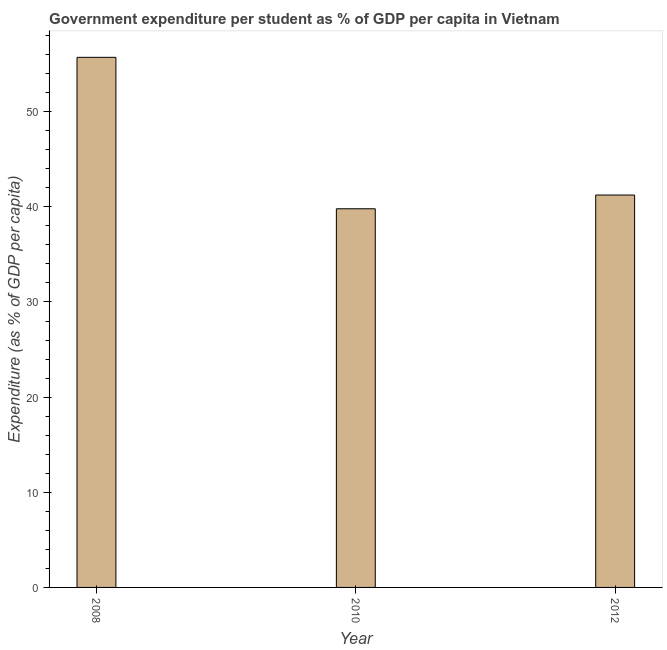What is the title of the graph?
Offer a very short reply. Government expenditure per student as % of GDP per capita in Vietnam. What is the label or title of the X-axis?
Ensure brevity in your answer.  Year. What is the label or title of the Y-axis?
Provide a succinct answer. Expenditure (as % of GDP per capita). What is the government expenditure per student in 2010?
Keep it short and to the point. 39.8. Across all years, what is the maximum government expenditure per student?
Offer a terse response. 55.71. Across all years, what is the minimum government expenditure per student?
Provide a succinct answer. 39.8. In which year was the government expenditure per student maximum?
Keep it short and to the point. 2008. What is the sum of the government expenditure per student?
Keep it short and to the point. 136.75. What is the difference between the government expenditure per student in 2008 and 2010?
Keep it short and to the point. 15.92. What is the average government expenditure per student per year?
Your answer should be compact. 45.58. What is the median government expenditure per student?
Ensure brevity in your answer.  41.24. In how many years, is the government expenditure per student greater than 48 %?
Your answer should be compact. 1. Do a majority of the years between 2010 and 2012 (inclusive) have government expenditure per student greater than 50 %?
Keep it short and to the point. No. What is the ratio of the government expenditure per student in 2008 to that in 2012?
Make the answer very short. 1.35. Is the government expenditure per student in 2008 less than that in 2012?
Offer a very short reply. No. What is the difference between the highest and the second highest government expenditure per student?
Offer a terse response. 14.47. Is the sum of the government expenditure per student in 2010 and 2012 greater than the maximum government expenditure per student across all years?
Provide a short and direct response. Yes. What is the difference between the highest and the lowest government expenditure per student?
Offer a very short reply. 15.92. In how many years, is the government expenditure per student greater than the average government expenditure per student taken over all years?
Offer a very short reply. 1. Are all the bars in the graph horizontal?
Your response must be concise. No. What is the difference between two consecutive major ticks on the Y-axis?
Make the answer very short. 10. What is the Expenditure (as % of GDP per capita) of 2008?
Make the answer very short. 55.71. What is the Expenditure (as % of GDP per capita) in 2010?
Your answer should be compact. 39.8. What is the Expenditure (as % of GDP per capita) in 2012?
Make the answer very short. 41.24. What is the difference between the Expenditure (as % of GDP per capita) in 2008 and 2010?
Provide a short and direct response. 15.92. What is the difference between the Expenditure (as % of GDP per capita) in 2008 and 2012?
Your answer should be compact. 14.47. What is the difference between the Expenditure (as % of GDP per capita) in 2010 and 2012?
Make the answer very short. -1.44. What is the ratio of the Expenditure (as % of GDP per capita) in 2008 to that in 2010?
Your answer should be very brief. 1.4. What is the ratio of the Expenditure (as % of GDP per capita) in 2008 to that in 2012?
Offer a very short reply. 1.35. 